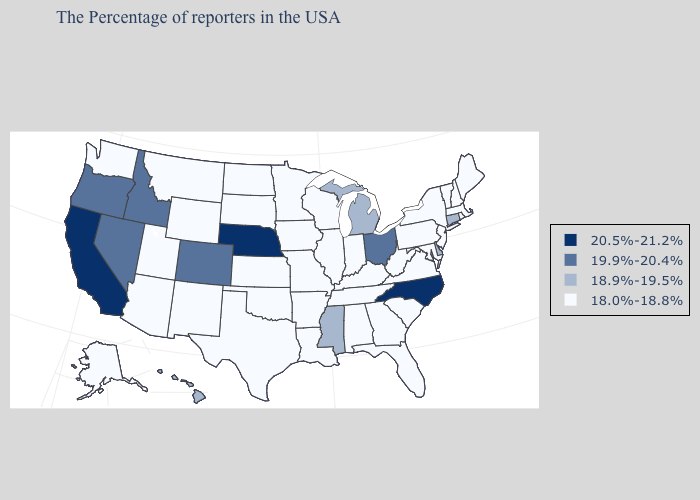Which states hav the highest value in the MidWest?
Short answer required. Nebraska. Name the states that have a value in the range 20.5%-21.2%?
Write a very short answer. North Carolina, Nebraska, California. Which states have the lowest value in the USA?
Short answer required. Maine, Massachusetts, Rhode Island, New Hampshire, Vermont, New York, New Jersey, Maryland, Pennsylvania, Virginia, South Carolina, West Virginia, Florida, Georgia, Kentucky, Indiana, Alabama, Tennessee, Wisconsin, Illinois, Louisiana, Missouri, Arkansas, Minnesota, Iowa, Kansas, Oklahoma, Texas, South Dakota, North Dakota, Wyoming, New Mexico, Utah, Montana, Arizona, Washington, Alaska. Name the states that have a value in the range 20.5%-21.2%?
Concise answer only. North Carolina, Nebraska, California. Does Maine have the highest value in the USA?
Give a very brief answer. No. What is the lowest value in the MidWest?
Short answer required. 18.0%-18.8%. Name the states that have a value in the range 19.9%-20.4%?
Quick response, please. Ohio, Colorado, Idaho, Nevada, Oregon. Name the states that have a value in the range 20.5%-21.2%?
Keep it brief. North Carolina, Nebraska, California. Name the states that have a value in the range 19.9%-20.4%?
Keep it brief. Ohio, Colorado, Idaho, Nevada, Oregon. Name the states that have a value in the range 19.9%-20.4%?
Answer briefly. Ohio, Colorado, Idaho, Nevada, Oregon. Name the states that have a value in the range 18.9%-19.5%?
Write a very short answer. Connecticut, Delaware, Michigan, Mississippi, Hawaii. What is the value of Louisiana?
Answer briefly. 18.0%-18.8%. Among the states that border Rhode Island , does Connecticut have the lowest value?
Keep it brief. No. What is the value of Kentucky?
Write a very short answer. 18.0%-18.8%. Among the states that border Louisiana , which have the highest value?
Concise answer only. Mississippi. 